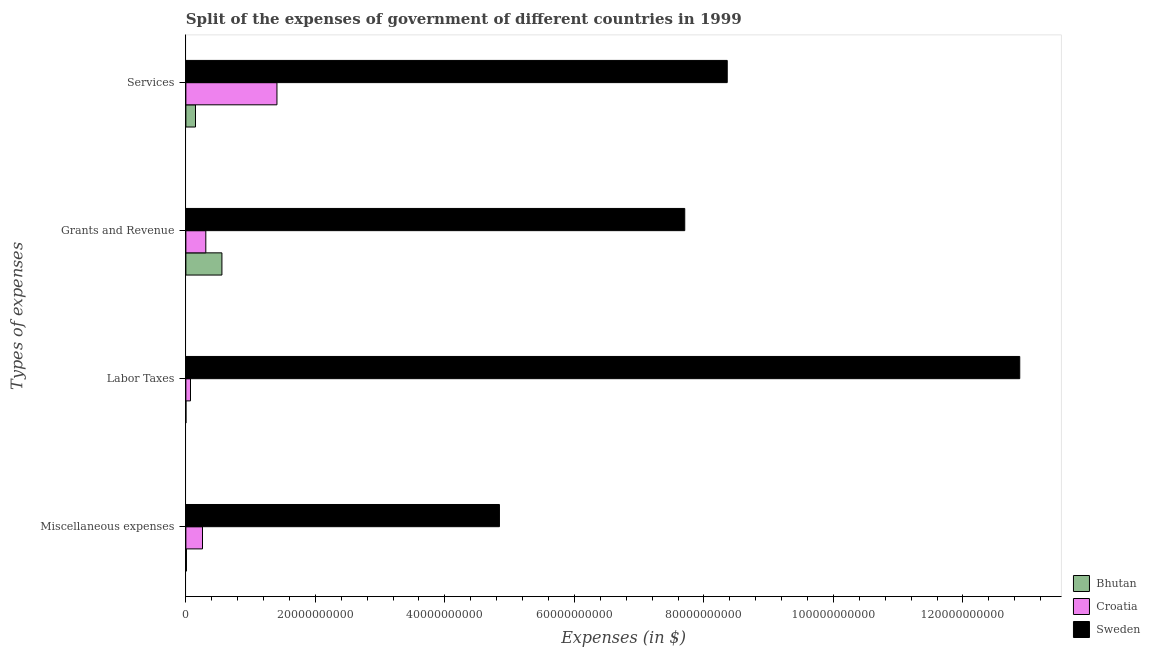How many different coloured bars are there?
Provide a succinct answer. 3. Are the number of bars per tick equal to the number of legend labels?
Ensure brevity in your answer.  Yes. Are the number of bars on each tick of the Y-axis equal?
Provide a short and direct response. Yes. How many bars are there on the 4th tick from the top?
Your answer should be compact. 3. How many bars are there on the 4th tick from the bottom?
Provide a succinct answer. 3. What is the label of the 3rd group of bars from the top?
Ensure brevity in your answer.  Labor Taxes. What is the amount spent on miscellaneous expenses in Bhutan?
Give a very brief answer. 8.63e+07. Across all countries, what is the maximum amount spent on labor taxes?
Your answer should be very brief. 1.29e+11. Across all countries, what is the minimum amount spent on miscellaneous expenses?
Keep it short and to the point. 8.63e+07. In which country was the amount spent on grants and revenue minimum?
Provide a short and direct response. Croatia. What is the total amount spent on grants and revenue in the graph?
Your answer should be compact. 8.57e+1. What is the difference between the amount spent on labor taxes in Sweden and that in Bhutan?
Make the answer very short. 1.29e+11. What is the difference between the amount spent on miscellaneous expenses in Sweden and the amount spent on labor taxes in Bhutan?
Give a very brief answer. 4.84e+1. What is the average amount spent on services per country?
Keep it short and to the point. 3.31e+1. What is the difference between the amount spent on labor taxes and amount spent on services in Bhutan?
Keep it short and to the point. -1.48e+09. What is the ratio of the amount spent on miscellaneous expenses in Bhutan to that in Croatia?
Offer a terse response. 0.03. Is the difference between the amount spent on grants and revenue in Croatia and Bhutan greater than the difference between the amount spent on labor taxes in Croatia and Bhutan?
Your answer should be very brief. No. What is the difference between the highest and the second highest amount spent on grants and revenue?
Your answer should be very brief. 7.15e+1. What is the difference between the highest and the lowest amount spent on services?
Give a very brief answer. 8.21e+1. In how many countries, is the amount spent on labor taxes greater than the average amount spent on labor taxes taken over all countries?
Give a very brief answer. 1. What does the 3rd bar from the top in Grants and Revenue represents?
Keep it short and to the point. Bhutan. What does the 2nd bar from the bottom in Miscellaneous expenses represents?
Give a very brief answer. Croatia. How many countries are there in the graph?
Your response must be concise. 3. What is the difference between two consecutive major ticks on the X-axis?
Your answer should be compact. 2.00e+1. Are the values on the major ticks of X-axis written in scientific E-notation?
Your response must be concise. No. Does the graph contain any zero values?
Provide a succinct answer. No. How many legend labels are there?
Your answer should be very brief. 3. How are the legend labels stacked?
Ensure brevity in your answer.  Vertical. What is the title of the graph?
Offer a terse response. Split of the expenses of government of different countries in 1999. Does "Mauritania" appear as one of the legend labels in the graph?
Keep it short and to the point. No. What is the label or title of the X-axis?
Offer a very short reply. Expenses (in $). What is the label or title of the Y-axis?
Make the answer very short. Types of expenses. What is the Expenses (in $) in Bhutan in Miscellaneous expenses?
Offer a very short reply. 8.63e+07. What is the Expenses (in $) of Croatia in Miscellaneous expenses?
Provide a short and direct response. 2.57e+09. What is the Expenses (in $) of Sweden in Miscellaneous expenses?
Provide a succinct answer. 4.84e+1. What is the Expenses (in $) in Bhutan in Labor Taxes?
Your answer should be very brief. 7.10e+06. What is the Expenses (in $) of Croatia in Labor Taxes?
Offer a very short reply. 7.14e+08. What is the Expenses (in $) in Sweden in Labor Taxes?
Provide a short and direct response. 1.29e+11. What is the Expenses (in $) in Bhutan in Grants and Revenue?
Your answer should be compact. 5.57e+09. What is the Expenses (in $) of Croatia in Grants and Revenue?
Ensure brevity in your answer.  3.08e+09. What is the Expenses (in $) in Sweden in Grants and Revenue?
Your answer should be very brief. 7.70e+1. What is the Expenses (in $) in Bhutan in Services?
Provide a succinct answer. 1.49e+09. What is the Expenses (in $) in Croatia in Services?
Ensure brevity in your answer.  1.41e+1. What is the Expenses (in $) of Sweden in Services?
Give a very brief answer. 8.36e+1. Across all Types of expenses, what is the maximum Expenses (in $) of Bhutan?
Give a very brief answer. 5.57e+09. Across all Types of expenses, what is the maximum Expenses (in $) of Croatia?
Provide a short and direct response. 1.41e+1. Across all Types of expenses, what is the maximum Expenses (in $) in Sweden?
Your response must be concise. 1.29e+11. Across all Types of expenses, what is the minimum Expenses (in $) in Bhutan?
Ensure brevity in your answer.  7.10e+06. Across all Types of expenses, what is the minimum Expenses (in $) in Croatia?
Ensure brevity in your answer.  7.14e+08. Across all Types of expenses, what is the minimum Expenses (in $) of Sweden?
Provide a succinct answer. 4.84e+1. What is the total Expenses (in $) in Bhutan in the graph?
Give a very brief answer. 7.15e+09. What is the total Expenses (in $) of Croatia in the graph?
Keep it short and to the point. 2.04e+1. What is the total Expenses (in $) of Sweden in the graph?
Make the answer very short. 3.38e+11. What is the difference between the Expenses (in $) of Bhutan in Miscellaneous expenses and that in Labor Taxes?
Provide a succinct answer. 7.92e+07. What is the difference between the Expenses (in $) in Croatia in Miscellaneous expenses and that in Labor Taxes?
Provide a short and direct response. 1.85e+09. What is the difference between the Expenses (in $) in Sweden in Miscellaneous expenses and that in Labor Taxes?
Provide a succinct answer. -8.04e+1. What is the difference between the Expenses (in $) in Bhutan in Miscellaneous expenses and that in Grants and Revenue?
Ensure brevity in your answer.  -5.48e+09. What is the difference between the Expenses (in $) of Croatia in Miscellaneous expenses and that in Grants and Revenue?
Give a very brief answer. -5.12e+08. What is the difference between the Expenses (in $) in Sweden in Miscellaneous expenses and that in Grants and Revenue?
Keep it short and to the point. -2.86e+1. What is the difference between the Expenses (in $) of Bhutan in Miscellaneous expenses and that in Services?
Provide a succinct answer. -1.40e+09. What is the difference between the Expenses (in $) in Croatia in Miscellaneous expenses and that in Services?
Your answer should be very brief. -1.15e+1. What is the difference between the Expenses (in $) in Sweden in Miscellaneous expenses and that in Services?
Provide a short and direct response. -3.52e+1. What is the difference between the Expenses (in $) in Bhutan in Labor Taxes and that in Grants and Revenue?
Provide a short and direct response. -5.56e+09. What is the difference between the Expenses (in $) of Croatia in Labor Taxes and that in Grants and Revenue?
Your answer should be compact. -2.36e+09. What is the difference between the Expenses (in $) in Sweden in Labor Taxes and that in Grants and Revenue?
Your answer should be compact. 5.17e+1. What is the difference between the Expenses (in $) in Bhutan in Labor Taxes and that in Services?
Make the answer very short. -1.48e+09. What is the difference between the Expenses (in $) in Croatia in Labor Taxes and that in Services?
Provide a succinct answer. -1.34e+1. What is the difference between the Expenses (in $) of Sweden in Labor Taxes and that in Services?
Offer a terse response. 4.52e+1. What is the difference between the Expenses (in $) of Bhutan in Grants and Revenue and that in Services?
Provide a short and direct response. 4.08e+09. What is the difference between the Expenses (in $) in Croatia in Grants and Revenue and that in Services?
Ensure brevity in your answer.  -1.10e+1. What is the difference between the Expenses (in $) of Sweden in Grants and Revenue and that in Services?
Offer a terse response. -6.56e+09. What is the difference between the Expenses (in $) of Bhutan in Miscellaneous expenses and the Expenses (in $) of Croatia in Labor Taxes?
Offer a very short reply. -6.28e+08. What is the difference between the Expenses (in $) in Bhutan in Miscellaneous expenses and the Expenses (in $) in Sweden in Labor Taxes?
Your response must be concise. -1.29e+11. What is the difference between the Expenses (in $) of Croatia in Miscellaneous expenses and the Expenses (in $) of Sweden in Labor Taxes?
Offer a terse response. -1.26e+11. What is the difference between the Expenses (in $) in Bhutan in Miscellaneous expenses and the Expenses (in $) in Croatia in Grants and Revenue?
Ensure brevity in your answer.  -2.99e+09. What is the difference between the Expenses (in $) in Bhutan in Miscellaneous expenses and the Expenses (in $) in Sweden in Grants and Revenue?
Provide a short and direct response. -7.70e+1. What is the difference between the Expenses (in $) in Croatia in Miscellaneous expenses and the Expenses (in $) in Sweden in Grants and Revenue?
Offer a terse response. -7.45e+1. What is the difference between the Expenses (in $) of Bhutan in Miscellaneous expenses and the Expenses (in $) of Croatia in Services?
Offer a terse response. -1.40e+1. What is the difference between the Expenses (in $) of Bhutan in Miscellaneous expenses and the Expenses (in $) of Sweden in Services?
Your answer should be very brief. -8.35e+1. What is the difference between the Expenses (in $) in Croatia in Miscellaneous expenses and the Expenses (in $) in Sweden in Services?
Your answer should be compact. -8.10e+1. What is the difference between the Expenses (in $) of Bhutan in Labor Taxes and the Expenses (in $) of Croatia in Grants and Revenue?
Ensure brevity in your answer.  -3.07e+09. What is the difference between the Expenses (in $) in Bhutan in Labor Taxes and the Expenses (in $) in Sweden in Grants and Revenue?
Give a very brief answer. -7.70e+1. What is the difference between the Expenses (in $) of Croatia in Labor Taxes and the Expenses (in $) of Sweden in Grants and Revenue?
Provide a short and direct response. -7.63e+1. What is the difference between the Expenses (in $) of Bhutan in Labor Taxes and the Expenses (in $) of Croatia in Services?
Your answer should be very brief. -1.41e+1. What is the difference between the Expenses (in $) of Bhutan in Labor Taxes and the Expenses (in $) of Sweden in Services?
Make the answer very short. -8.36e+1. What is the difference between the Expenses (in $) of Croatia in Labor Taxes and the Expenses (in $) of Sweden in Services?
Your answer should be compact. -8.29e+1. What is the difference between the Expenses (in $) in Bhutan in Grants and Revenue and the Expenses (in $) in Croatia in Services?
Keep it short and to the point. -8.50e+09. What is the difference between the Expenses (in $) of Bhutan in Grants and Revenue and the Expenses (in $) of Sweden in Services?
Keep it short and to the point. -7.80e+1. What is the difference between the Expenses (in $) of Croatia in Grants and Revenue and the Expenses (in $) of Sweden in Services?
Provide a succinct answer. -8.05e+1. What is the average Expenses (in $) of Bhutan per Types of expenses?
Give a very brief answer. 1.79e+09. What is the average Expenses (in $) of Croatia per Types of expenses?
Provide a short and direct response. 5.11e+09. What is the average Expenses (in $) of Sweden per Types of expenses?
Offer a terse response. 8.45e+1. What is the difference between the Expenses (in $) of Bhutan and Expenses (in $) of Croatia in Miscellaneous expenses?
Give a very brief answer. -2.48e+09. What is the difference between the Expenses (in $) of Bhutan and Expenses (in $) of Sweden in Miscellaneous expenses?
Provide a succinct answer. -4.83e+1. What is the difference between the Expenses (in $) in Croatia and Expenses (in $) in Sweden in Miscellaneous expenses?
Ensure brevity in your answer.  -4.59e+1. What is the difference between the Expenses (in $) in Bhutan and Expenses (in $) in Croatia in Labor Taxes?
Your answer should be compact. -7.07e+08. What is the difference between the Expenses (in $) in Bhutan and Expenses (in $) in Sweden in Labor Taxes?
Give a very brief answer. -1.29e+11. What is the difference between the Expenses (in $) in Croatia and Expenses (in $) in Sweden in Labor Taxes?
Provide a succinct answer. -1.28e+11. What is the difference between the Expenses (in $) in Bhutan and Expenses (in $) in Croatia in Grants and Revenue?
Make the answer very short. 2.49e+09. What is the difference between the Expenses (in $) in Bhutan and Expenses (in $) in Sweden in Grants and Revenue?
Offer a terse response. -7.15e+1. What is the difference between the Expenses (in $) of Croatia and Expenses (in $) of Sweden in Grants and Revenue?
Offer a very short reply. -7.40e+1. What is the difference between the Expenses (in $) in Bhutan and Expenses (in $) in Croatia in Services?
Make the answer very short. -1.26e+1. What is the difference between the Expenses (in $) of Bhutan and Expenses (in $) of Sweden in Services?
Your answer should be very brief. -8.21e+1. What is the difference between the Expenses (in $) in Croatia and Expenses (in $) in Sweden in Services?
Make the answer very short. -6.95e+1. What is the ratio of the Expenses (in $) in Bhutan in Miscellaneous expenses to that in Labor Taxes?
Your answer should be very brief. 12.15. What is the ratio of the Expenses (in $) in Croatia in Miscellaneous expenses to that in Labor Taxes?
Offer a very short reply. 3.59. What is the ratio of the Expenses (in $) in Sweden in Miscellaneous expenses to that in Labor Taxes?
Make the answer very short. 0.38. What is the ratio of the Expenses (in $) in Bhutan in Miscellaneous expenses to that in Grants and Revenue?
Provide a short and direct response. 0.02. What is the ratio of the Expenses (in $) in Croatia in Miscellaneous expenses to that in Grants and Revenue?
Your response must be concise. 0.83. What is the ratio of the Expenses (in $) in Sweden in Miscellaneous expenses to that in Grants and Revenue?
Offer a very short reply. 0.63. What is the ratio of the Expenses (in $) in Bhutan in Miscellaneous expenses to that in Services?
Offer a very short reply. 0.06. What is the ratio of the Expenses (in $) in Croatia in Miscellaneous expenses to that in Services?
Provide a short and direct response. 0.18. What is the ratio of the Expenses (in $) of Sweden in Miscellaneous expenses to that in Services?
Offer a terse response. 0.58. What is the ratio of the Expenses (in $) of Bhutan in Labor Taxes to that in Grants and Revenue?
Your answer should be very brief. 0. What is the ratio of the Expenses (in $) in Croatia in Labor Taxes to that in Grants and Revenue?
Keep it short and to the point. 0.23. What is the ratio of the Expenses (in $) in Sweden in Labor Taxes to that in Grants and Revenue?
Make the answer very short. 1.67. What is the ratio of the Expenses (in $) of Bhutan in Labor Taxes to that in Services?
Keep it short and to the point. 0. What is the ratio of the Expenses (in $) of Croatia in Labor Taxes to that in Services?
Make the answer very short. 0.05. What is the ratio of the Expenses (in $) in Sweden in Labor Taxes to that in Services?
Provide a short and direct response. 1.54. What is the ratio of the Expenses (in $) in Bhutan in Grants and Revenue to that in Services?
Your answer should be very brief. 3.75. What is the ratio of the Expenses (in $) in Croatia in Grants and Revenue to that in Services?
Give a very brief answer. 0.22. What is the ratio of the Expenses (in $) in Sweden in Grants and Revenue to that in Services?
Your answer should be very brief. 0.92. What is the difference between the highest and the second highest Expenses (in $) in Bhutan?
Make the answer very short. 4.08e+09. What is the difference between the highest and the second highest Expenses (in $) of Croatia?
Provide a succinct answer. 1.10e+1. What is the difference between the highest and the second highest Expenses (in $) in Sweden?
Your answer should be very brief. 4.52e+1. What is the difference between the highest and the lowest Expenses (in $) of Bhutan?
Your answer should be very brief. 5.56e+09. What is the difference between the highest and the lowest Expenses (in $) in Croatia?
Your answer should be very brief. 1.34e+1. What is the difference between the highest and the lowest Expenses (in $) in Sweden?
Keep it short and to the point. 8.04e+1. 